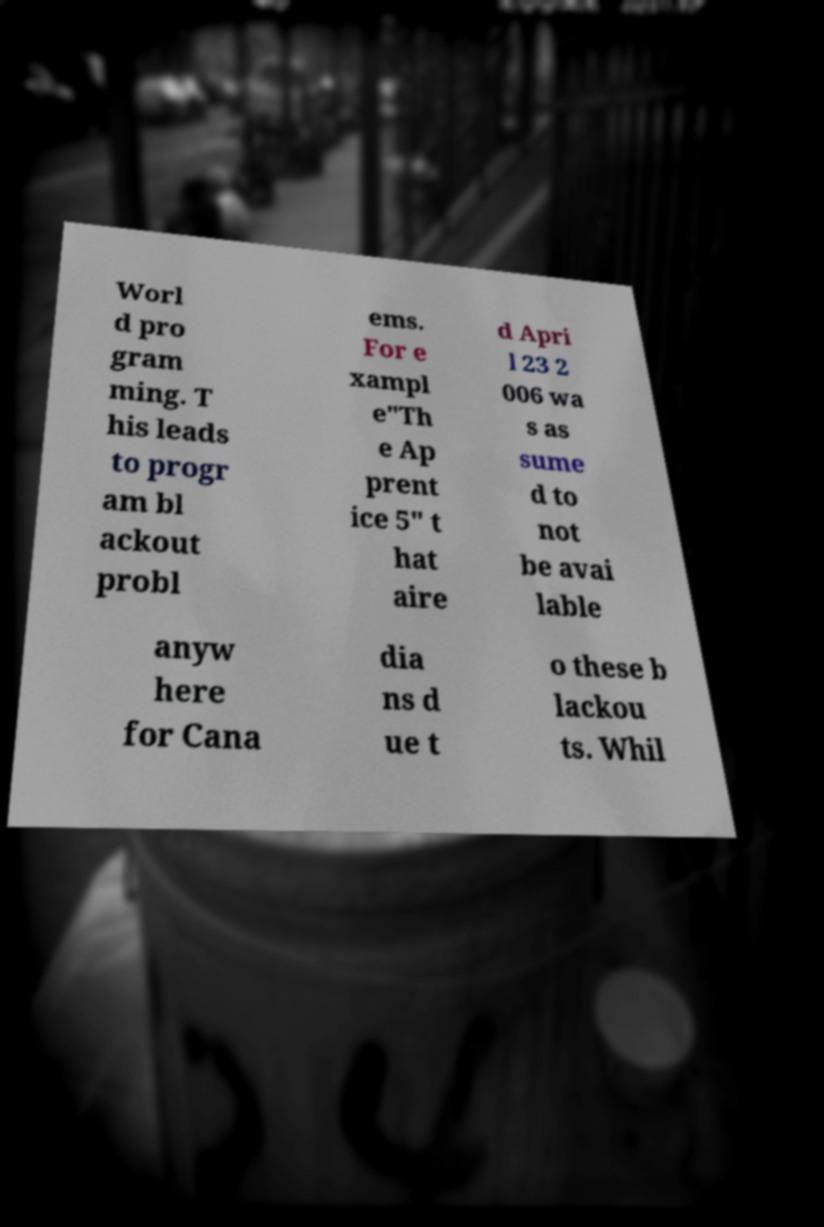Could you extract and type out the text from this image? Worl d pro gram ming. T his leads to progr am bl ackout probl ems. For e xampl e"Th e Ap prent ice 5" t hat aire d Apri l 23 2 006 wa s as sume d to not be avai lable anyw here for Cana dia ns d ue t o these b lackou ts. Whil 